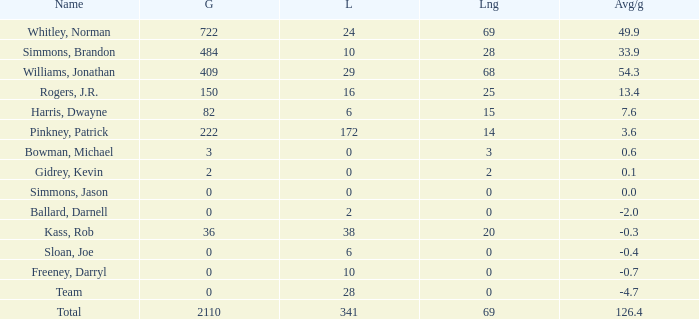What is the lowest Long, when Name is Kass, Rob, and when Avg/g is less than -0.30000000000000004? None. 